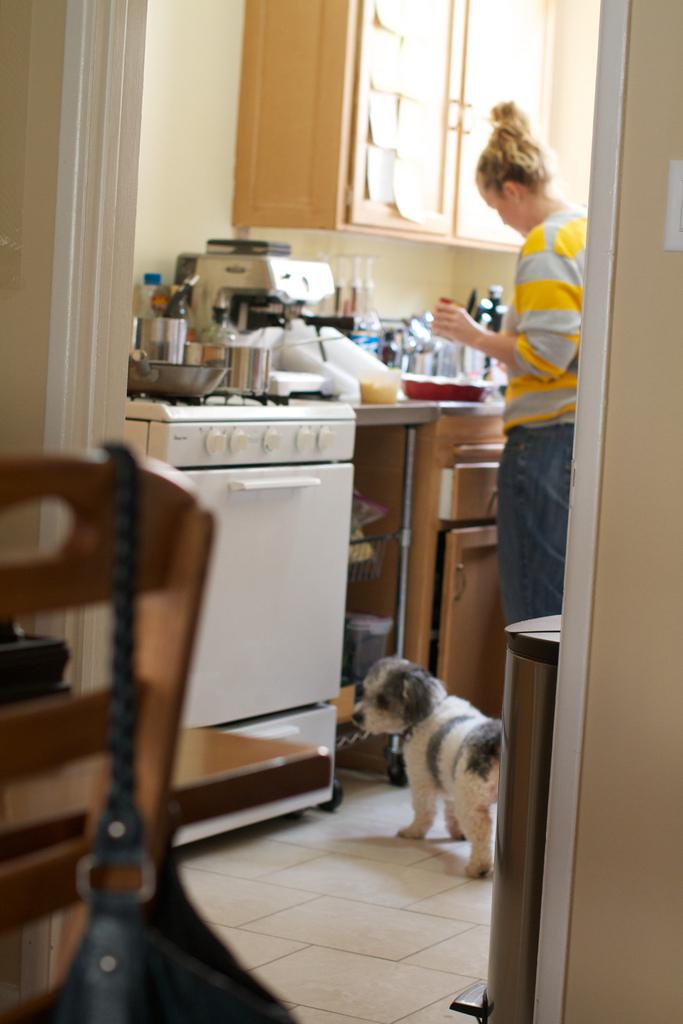Question: what is the woman doing?
Choices:
A. Sewing.
B. Vacuuming.
C. Dreaming of escape.
D. Cooking.
Answer with the letter. Answer: D Question: what animal is with the woman?
Choices:
A. Cat.
B. Racoon.
C. Pet piranha.
D. Dog.
Answer with the letter. Answer: D Question: what clothes is the woman wearing?
Choices:
A. Shirt and jeans.
B. Khakhis and blouse.
C. Wool pants and blazer.
D. Chemise.
Answer with the letter. Answer: A Question: what color hair does the woman have?
Choices:
A. Gray.
B. Brown.
C. Red.
D. Blond.
Answer with the letter. Answer: D Question: what color is the dog?
Choices:
A. Black and beige.
B. Brindle and gray.
C. Gray and white.
D. Brown.
Answer with the letter. Answer: C Question: where is the woman located?
Choices:
A. In a bedroom.
B. In a kitchen.
C. In a library.
D. In a bathroom.
Answer with the letter. Answer: B Question: where does this scene take place?
Choices:
A. In the den.
B. In the kitchen.
C. In the bedroom.
D. In the living room.
Answer with the letter. Answer: B Question: where was the scene?
Choices:
A. Bedroom.
B. Kitchen.
C. Living room.
D. Bathroom.
Answer with the letter. Answer: B Question: what color is the woman's hair?
Choices:
A. Black.
B. Brown.
C. Blonde.
D. Red.
Answer with the letter. Answer: C Question: where is the silver and black trash can?
Choices:
A. In the bathroom.
B. On the porch.
C. Kitchen.
D. Next to the elevator.
Answer with the letter. Answer: C Question: what is on floor?
Choices:
A. Dirt.
B. Dust.
C. Paint.
D. Tiles.
Answer with the letter. Answer: D Question: what is red?
Choices:
A. Blood.
B. Lipstick.
C. Frying pan.
D. Bowl.
Answer with the letter. Answer: C Question: what color is the wall?
Choices:
A. While.
B. Brown.
C. Grey.
D. Red.
Answer with the letter. Answer: A Question: who is looking to its left?
Choices:
A. Cat.
B. Dog.
C. Horse.
D. Lizard.
Answer with the letter. Answer: B Question: what is white?
Choices:
A. Stove.
B. The fence.
C. The shirt.
D. The jacket.
Answer with the letter. Answer: A 